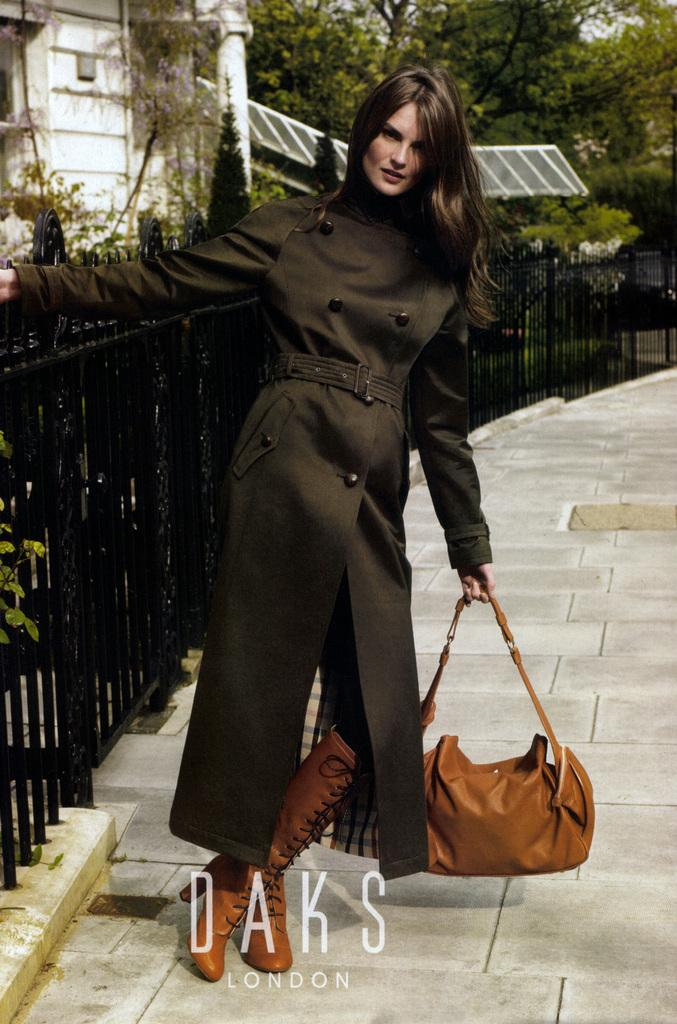Who or what is present in the image? There is a person in the image. What type of footwear is the person wearing? The person is wearing brown boots. What is the person holding in the image? The person is holding a brown bag. What can be seen in the background of the image? There is fencing, a building, and trees in the image. What type of meat is being served at the amusement park in the image? There is no amusement park or meat present in the image. How many mice can be seen playing near the trees in the image? There are no mice present in the image; only the person, brown boots, brown bag, fencing, building, and trees can be seen. 